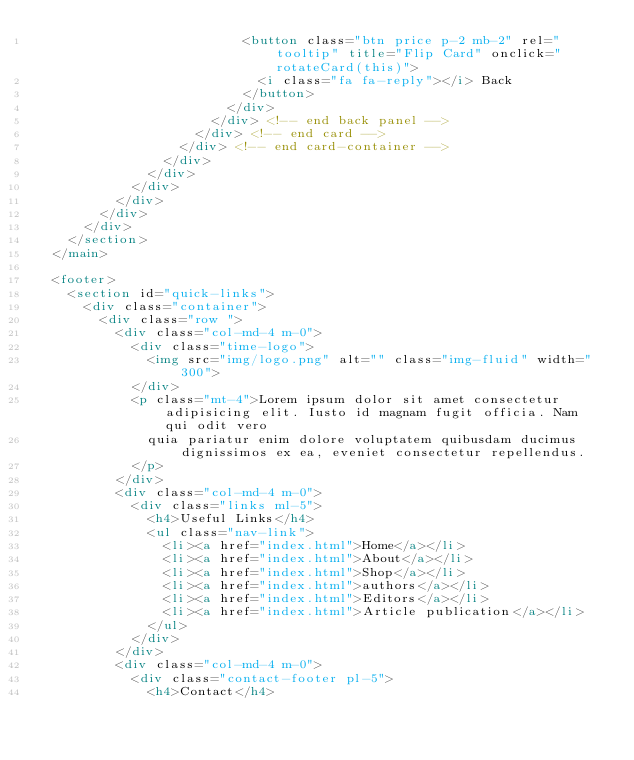<code> <loc_0><loc_0><loc_500><loc_500><_HTML_>                          <button class="btn price p-2 mb-2" rel="tooltip" title="Flip Card" onclick="rotateCard(this)">
                            <i class="fa fa-reply"></i> Back
                          </button>
                        </div>
                      </div> <!-- end back panel -->
                    </div> <!-- end card -->
                  </div> <!-- end card-container -->
                </div>
              </div>
            </div>
          </div>
        </div>
      </div>
    </section>
  </main>

  <footer>
    <section id="quick-links">
      <div class="container">
        <div class="row ">
          <div class="col-md-4 m-0">
            <div class="time-logo">
              <img src="img/logo.png" alt="" class="img-fluid" width="300">
            </div>
            <p class="mt-4">Lorem ipsum dolor sit amet consectetur adipisicing elit. Iusto id magnam fugit officia. Nam qui odit vero
              quia pariatur enim dolore voluptatem quibusdam ducimus dignissimos ex ea, eveniet consectetur repellendus.
            </p>
          </div>
          <div class="col-md-4 m-0">
            <div class="links ml-5">
              <h4>Useful Links</h4>
              <ul class="nav-link">
                <li><a href="index.html">Home</a></li>
                <li><a href="index.html">About</a></li>
                <li><a href="index.html">Shop</a></li>
                <li><a href="index.html">authors</a></li>
                <li><a href="index.html">Editors</a></li>
                <li><a href="index.html">Article publication</a></li>
              </ul>
            </div>
          </div>
          <div class="col-md-4 m-0">
            <div class="contact-footer pl-5">
              <h4>Contact</h4></code> 